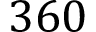<formula> <loc_0><loc_0><loc_500><loc_500>3 6 0</formula> 